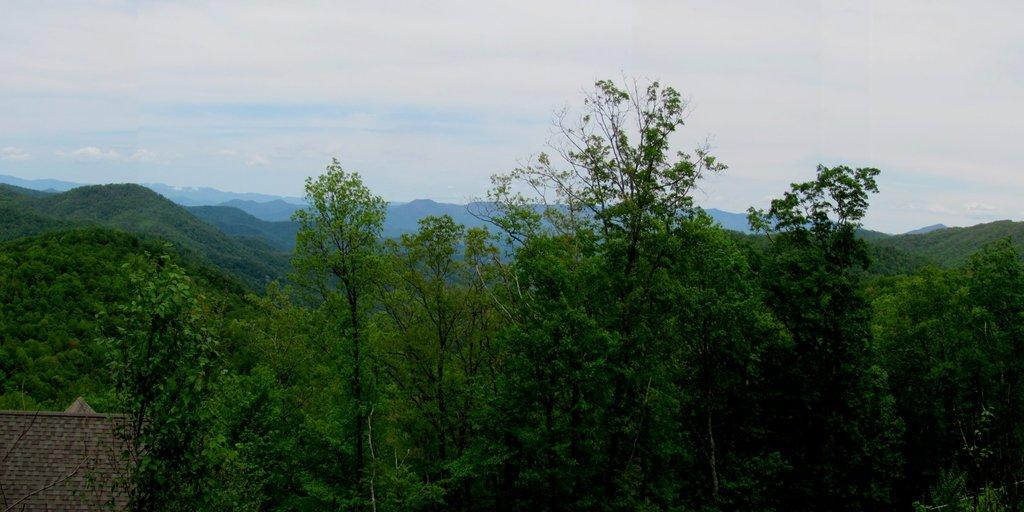Where was the picture taken? The picture was clicked outside. What can be seen in the foreground of the image? There are trees and an object in the foreground of the image. What is visible in the background of the image? There is a sky and hills visible in the background of the image. What is the chance of snowfall in the image? There is no indication of snowfall or winter weather in the image, so it's not possible to determine the chance of snowfall. 